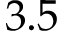<formula> <loc_0><loc_0><loc_500><loc_500>3 . 5</formula> 